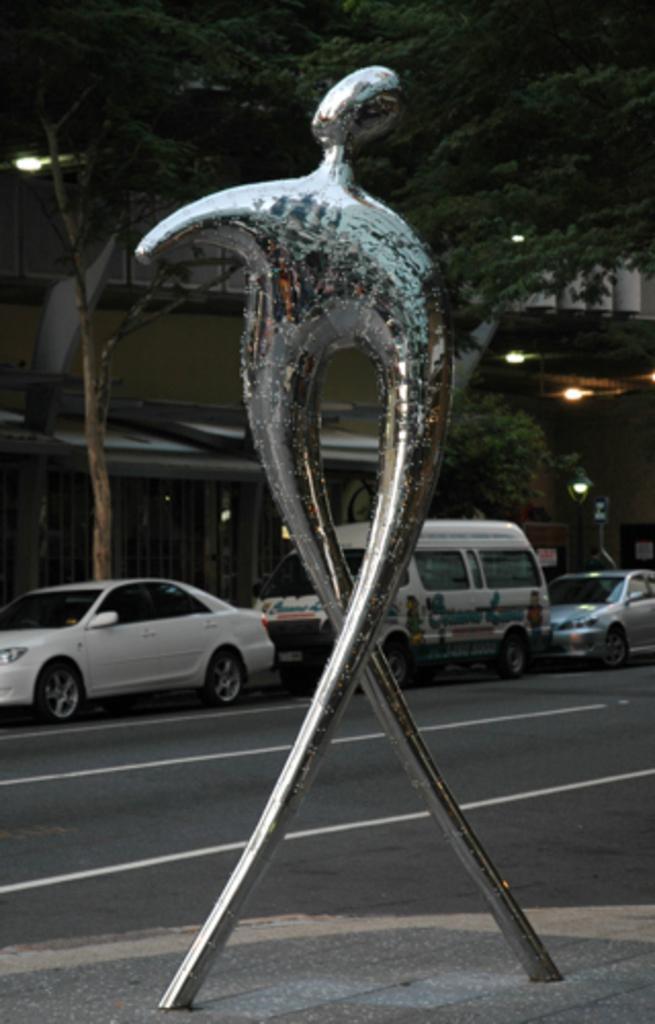Describe this image in one or two sentences. In this image there is an iconic model on the road, beside the road there are few vehicles parked and there are trees and houses. 